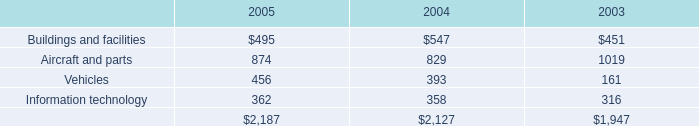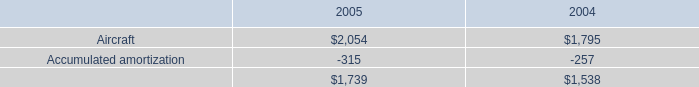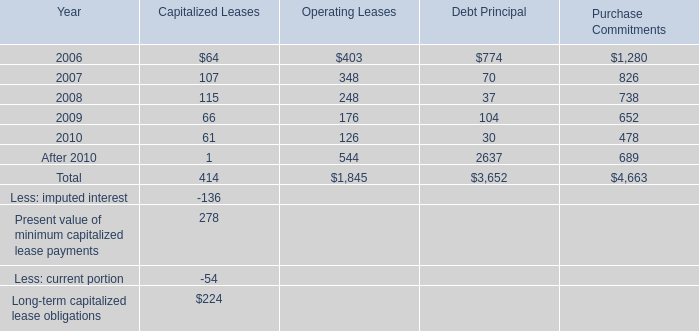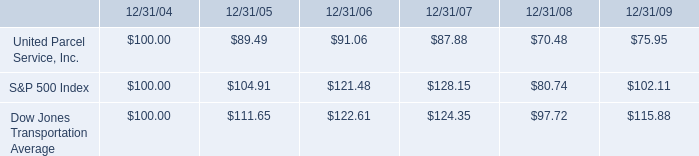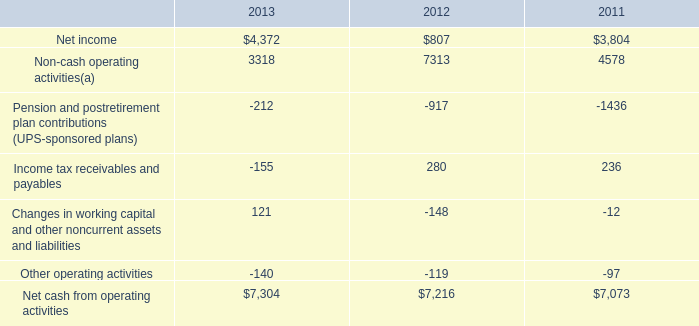What is the growing rate of Buildings and facilities in Table 0 in the years with the least Aircraft in Table 1? 
Computations: ((547 - 451) / 451)
Answer: 0.21286. 